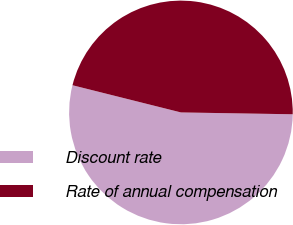Convert chart to OTSL. <chart><loc_0><loc_0><loc_500><loc_500><pie_chart><fcel>Discount rate<fcel>Rate of annual compensation<nl><fcel>53.65%<fcel>46.35%<nl></chart> 